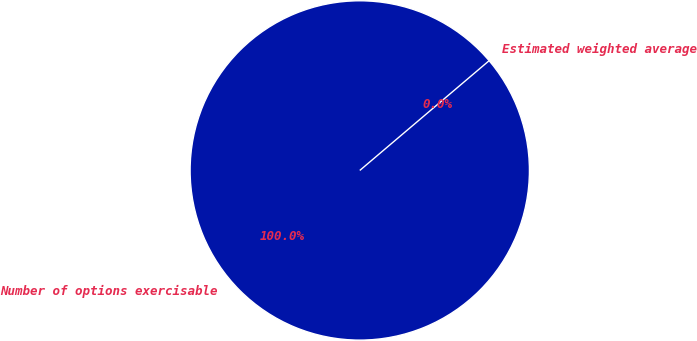Convert chart. <chart><loc_0><loc_0><loc_500><loc_500><pie_chart><fcel>Number of options exercisable<fcel>Estimated weighted average<nl><fcel>100.0%<fcel>0.0%<nl></chart> 